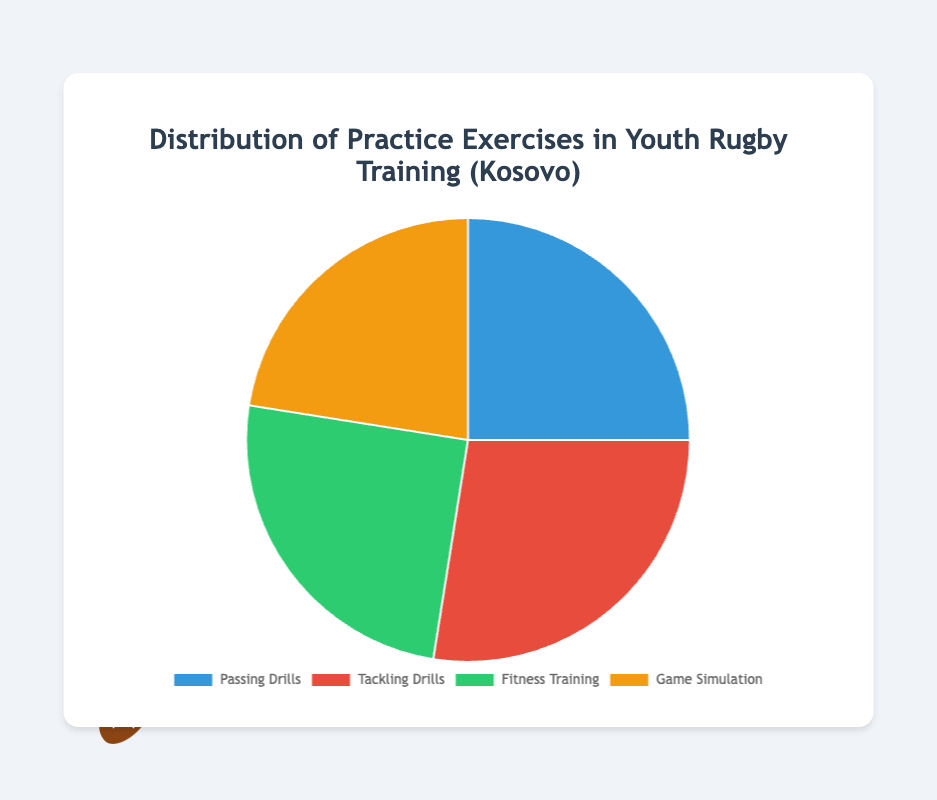Which type of drill has the largest percentage share? From the pie chart, Passing Drills have a 25%, Tackling Drills have 27.5%, Fitness Training has 25%, and Game Simulation has 22.5%. Tackling Drills have the largest share.
Answer: Tackling Drills How much more percentage does Tackling Drills have compared to Game Simulation? Tackling Drills have 27.5% and Game Simulation has 22.5%. The difference is 27.5% - 22.5% = 5%.
Answer: 5% What is the average percentage share of Fitness Training and Game Simulation? Fitness Training is 25% and Game Simulation is 22.5%. Their average is (25% + 22.5%) / 2 = 23.75%.
Answer: 23.75% Which type of drill has the smallest percentage share? From the pie chart, Passing Drills have 25%, Tackling Drills have 27.5%, Fitness Training has 25%, and Game Simulation has 22.5%. Game Simulation has the smallest share.
Answer: Game Simulation Are the shares of Passing Drills and Fitness Training equal? The pie chart shows both Passing Drills and Fitness Training at 25%. Since both are the same, the answer is yes.
Answer: Yes What is the total percentage share of Tackling Drills and Passing Drills combined? Tackling Drills are 27.5% and Passing Drills are 25%. Their combined share is 27.5% + 25% = 52.5%.
Answer: 52.5% Which two types of drills have the closest percentage share? Reviewing the pie chart, Passing Drills and Fitness Training both have 25% which is the same and thus the closest.
Answer: Passing Drills and Fitness Training What percentage of the training does not involve Game Simulation? Game Simulation percentage is 22.5%. The non-involvement percentage is 100% - 22.5% = 77.5%.
Answer: 77.5% If Tackling Drills were reduced by 5%, which drill would then have the highest percentage share? Tackling Drills would then be 27.5% - 5% = 22.5%. Both Passing Drills and Fitness Training would now be the highest at 25%.
Answer: Passing Drills and Fitness Training 